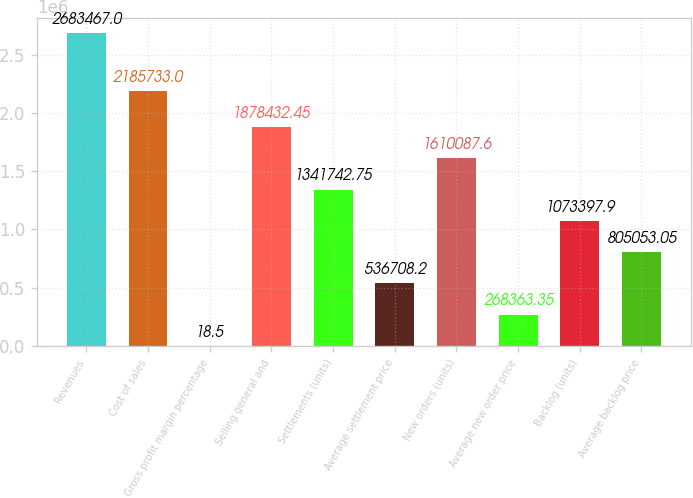<chart> <loc_0><loc_0><loc_500><loc_500><bar_chart><fcel>Revenues<fcel>Cost of sales<fcel>Gross profit margin percentage<fcel>Selling general and<fcel>Settlements (units)<fcel>Average settlement price<fcel>New orders (units)<fcel>Average new order price<fcel>Backlog (units)<fcel>Average backlog price<nl><fcel>2.68347e+06<fcel>2.18573e+06<fcel>18.5<fcel>1.87843e+06<fcel>1.34174e+06<fcel>536708<fcel>1.61009e+06<fcel>268363<fcel>1.0734e+06<fcel>805053<nl></chart> 